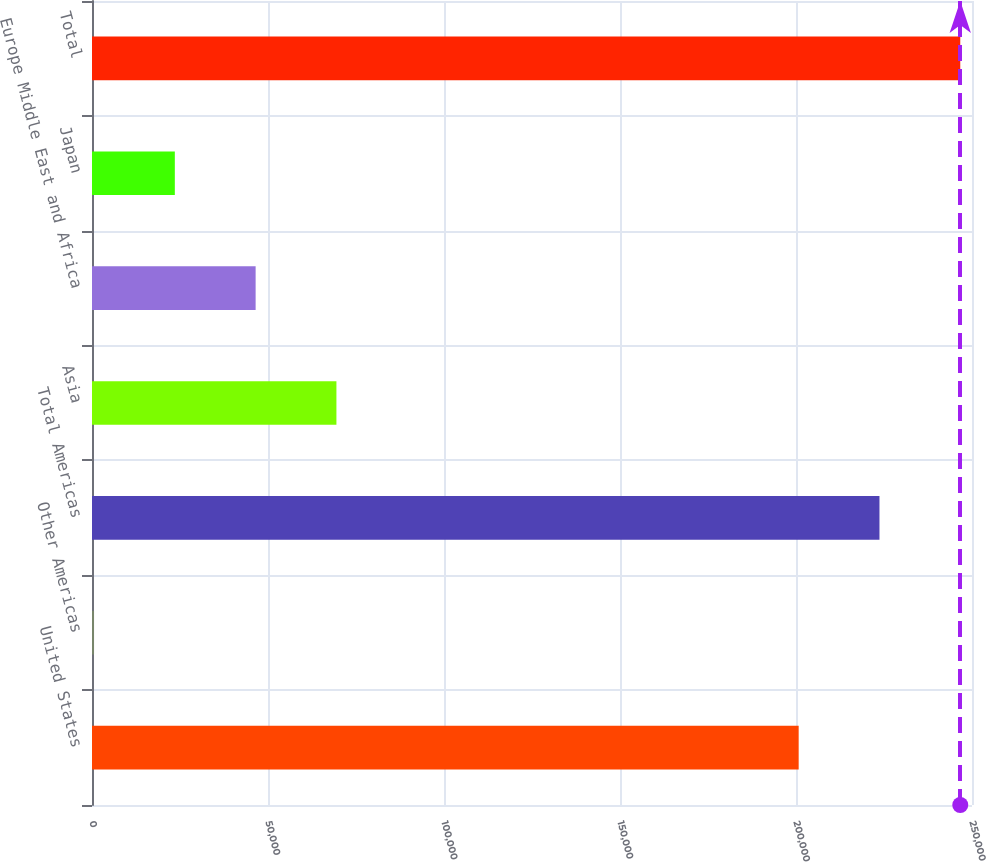Convert chart to OTSL. <chart><loc_0><loc_0><loc_500><loc_500><bar_chart><fcel>United States<fcel>Other Americas<fcel>Total Americas<fcel>Asia<fcel>Europe Middle East and Africa<fcel>Japan<fcel>Total<nl><fcel>200760<fcel>578<fcel>223713<fcel>69438.2<fcel>46484.8<fcel>23531.4<fcel>246667<nl></chart> 